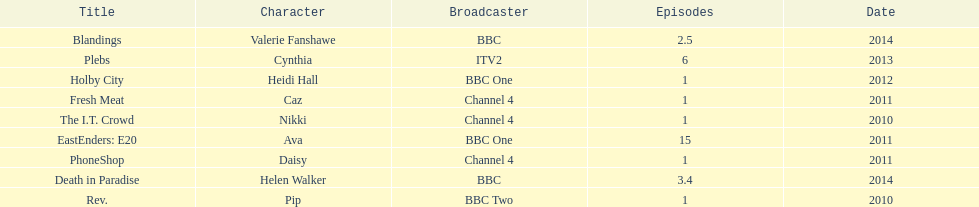Which broadcaster hosted 3 titles but they had only 1 episode? Channel 4. 